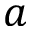Convert formula to latex. <formula><loc_0><loc_0><loc_500><loc_500>a</formula> 